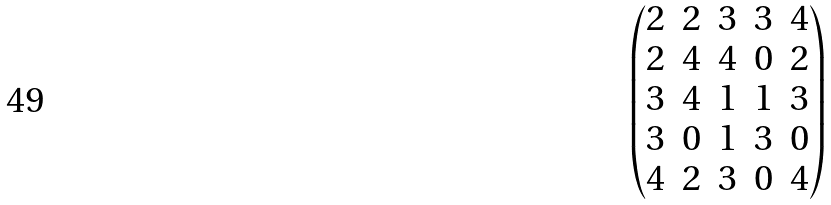Convert formula to latex. <formula><loc_0><loc_0><loc_500><loc_500>\begin{pmatrix} 2 & 2 & 3 & 3 & 4 \\ 2 & 4 & 4 & 0 & 2 \\ 3 & 4 & 1 & 1 & 3 \\ 3 & 0 & 1 & 3 & 0 \\ 4 & 2 & 3 & 0 & 4 \end{pmatrix}</formula> 